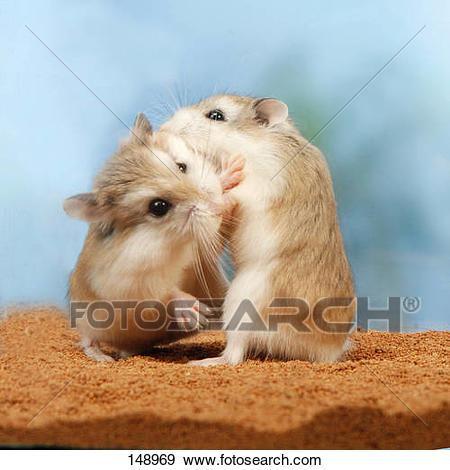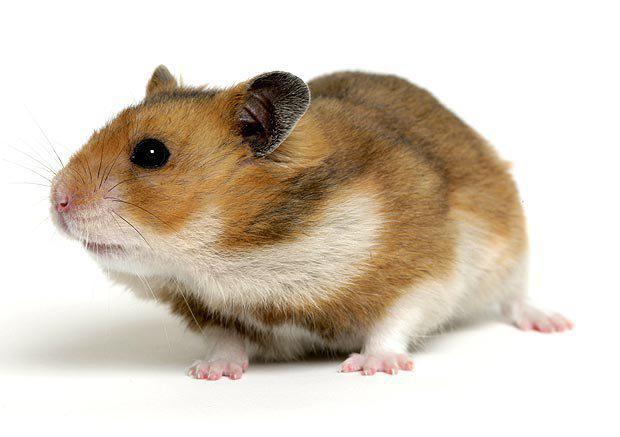The first image is the image on the left, the second image is the image on the right. Analyze the images presented: Is the assertion "There are in total three hamsters in the images." valid? Answer yes or no. Yes. The first image is the image on the left, the second image is the image on the right. Analyze the images presented: Is the assertion "There is one pair of brown and white hamsters fighting with each other in the image on the left." valid? Answer yes or no. Yes. 